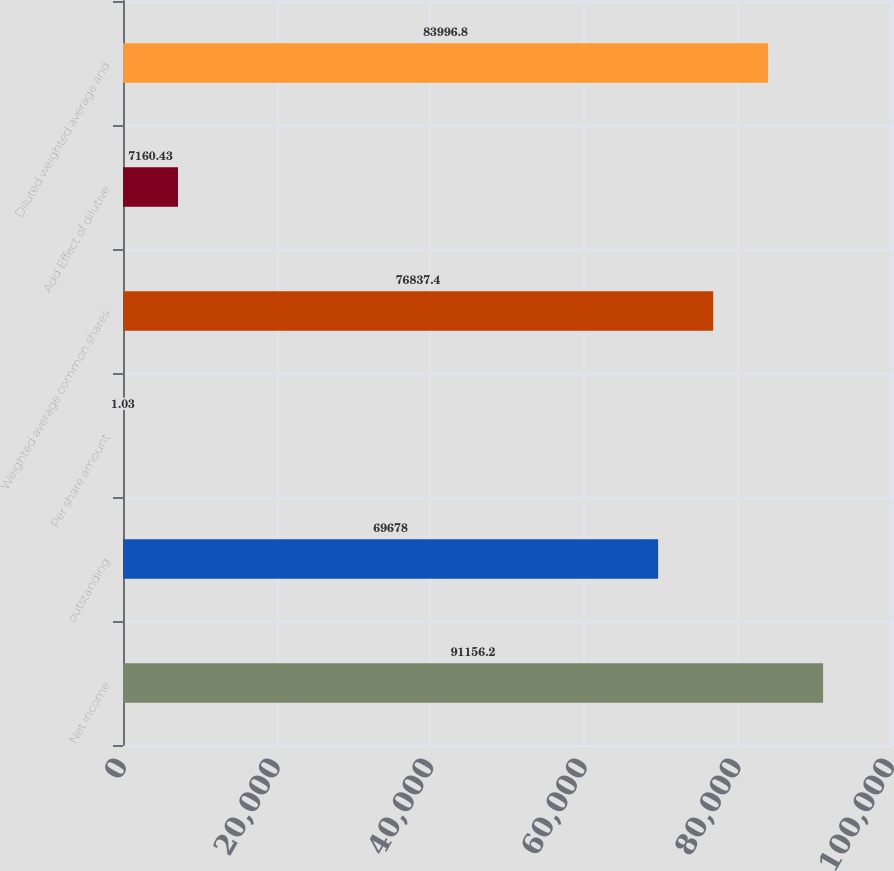<chart> <loc_0><loc_0><loc_500><loc_500><bar_chart><fcel>Net income<fcel>outstanding<fcel>Per share amount<fcel>Weighted average common shares<fcel>Add Effect of dilutive<fcel>Diluted weighted average and<nl><fcel>91156.2<fcel>69678<fcel>1.03<fcel>76837.4<fcel>7160.43<fcel>83996.8<nl></chart> 